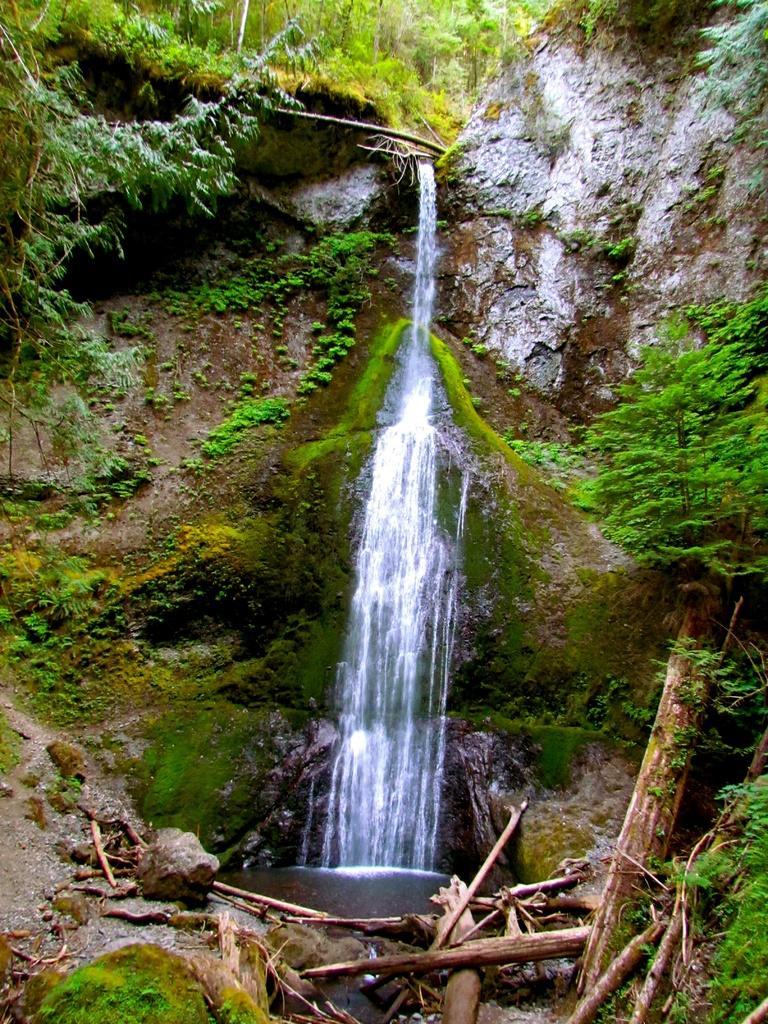In one or two sentences, can you explain what this image depicts? In this picture , in the middle is the waterfall and on the right side are plants and at bottom are wood. 